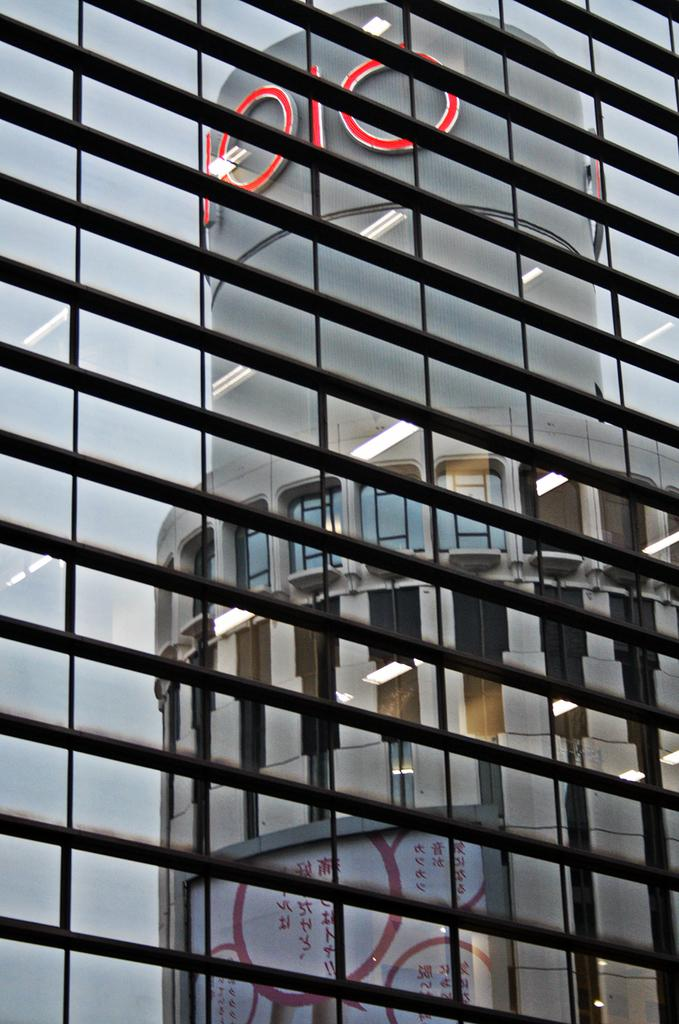What is the main structure in the foreground of the image? There is a building in the foreground of the image. What feature can be observed on the building? The building has glass doors. What can be seen through the glass doors? A reflection of a building and lights is visible through the glass doors. Is there any text present on the building? Yes, there is text on the building. How many cherries are hanging from the leg in the image? There is no leg or cherries present in the image. What type of weather can be inferred from the image? The provided facts do not give any information about the weather, so it cannot be inferred from the image. 